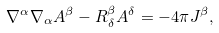Convert formula to latex. <formula><loc_0><loc_0><loc_500><loc_500>\nabla ^ { \alpha } \nabla _ { \alpha } A ^ { \beta } - R _ { \delta } ^ { \beta } A ^ { \delta } = - 4 \pi J ^ { \beta } ,</formula> 